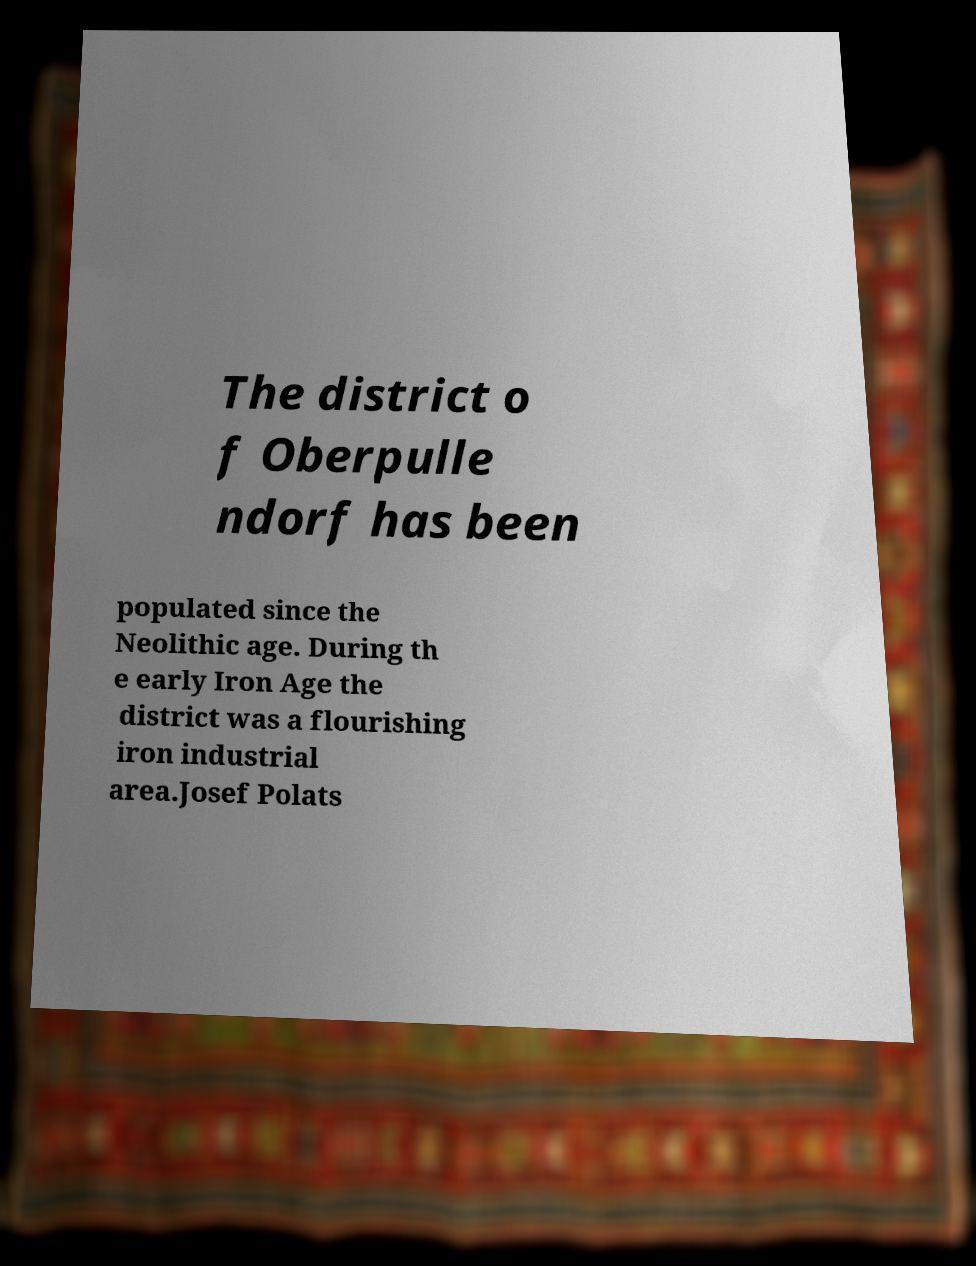Can you read and provide the text displayed in the image?This photo seems to have some interesting text. Can you extract and type it out for me? The district o f Oberpulle ndorf has been populated since the Neolithic age. During th e early Iron Age the district was a flourishing iron industrial area.Josef Polats 